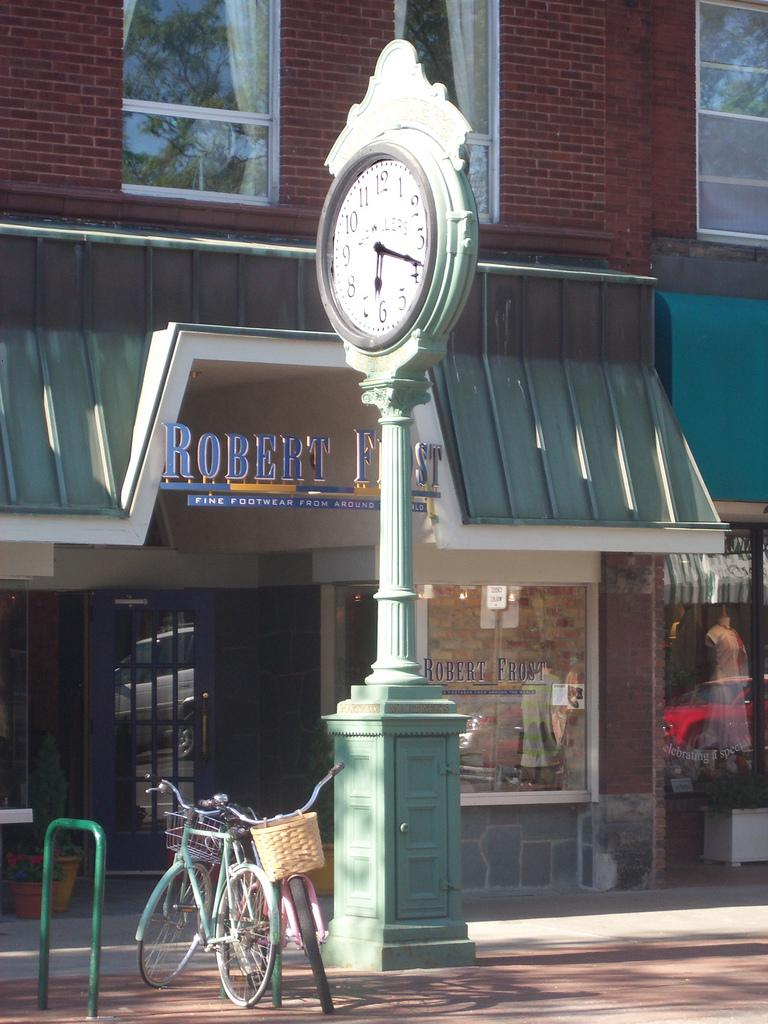Question: what time is on the clock?
Choices:
A. 7:30.
B. 12:00.
C. 6:20.
D. 4:45.
Answer with the letter. Answer: C Question: how many bicycles are parked?
Choices:
A. Two.
B. Six.
C. Three.
D. One.
Answer with the letter. Answer: A Question: what color is the clock?
Choices:
A. Red.
B. Green.
C. Blue.
D. Yellow.
Answer with the letter. Answer: B Question: what is the building made of?
Choices:
A. Stone.
B. Wood.
C. Brick.
D. Steel.
Answer with the letter. Answer: C Question: what color is the door?
Choices:
A. Red.
B. White.
C. Purple.
D. Brown.
Answer with the letter. Answer: C Question: where are the curtains?
Choices:
A. In the living room windows.
B. In the den windows.
C. In the bathroom windows.
D. In the upstairs windows.
Answer with the letter. Answer: D Question: what does the shop sell?
Choices:
A. Clothing.
B. Footwear.
C. Jewelry.
D. Accessories.
Answer with the letter. Answer: B Question: what time is it approximately?
Choices:
A. 6:19.
B. 5:19.
C. 8:19.
D. 9:19.
Answer with the letter. Answer: A Question: what is cast on the ground?
Choices:
A. Shadows.
B. Rain.
C. Hail.
D. Sleet.
Answer with the letter. Answer: A Question: how many bikes have a wicker basket?
Choices:
A. One.
B. None.
C. Some.
D. Two.
Answer with the letter. Answer: A Question: what color car is reflected in the window?
Choices:
A. White.
B. Orange.
C. Red.
D. Blue.
Answer with the letter. Answer: C Question: what does the sign indicate the shop sells?
Choices:
A. Car parts.
B. Footwear.
C. Lingerie.
D. Tobacco.
Answer with the letter. Answer: B Question: how many bikes have baskets?
Choices:
A. Three.
B. Two.
C. One.
D. None.
Answer with the letter. Answer: B 